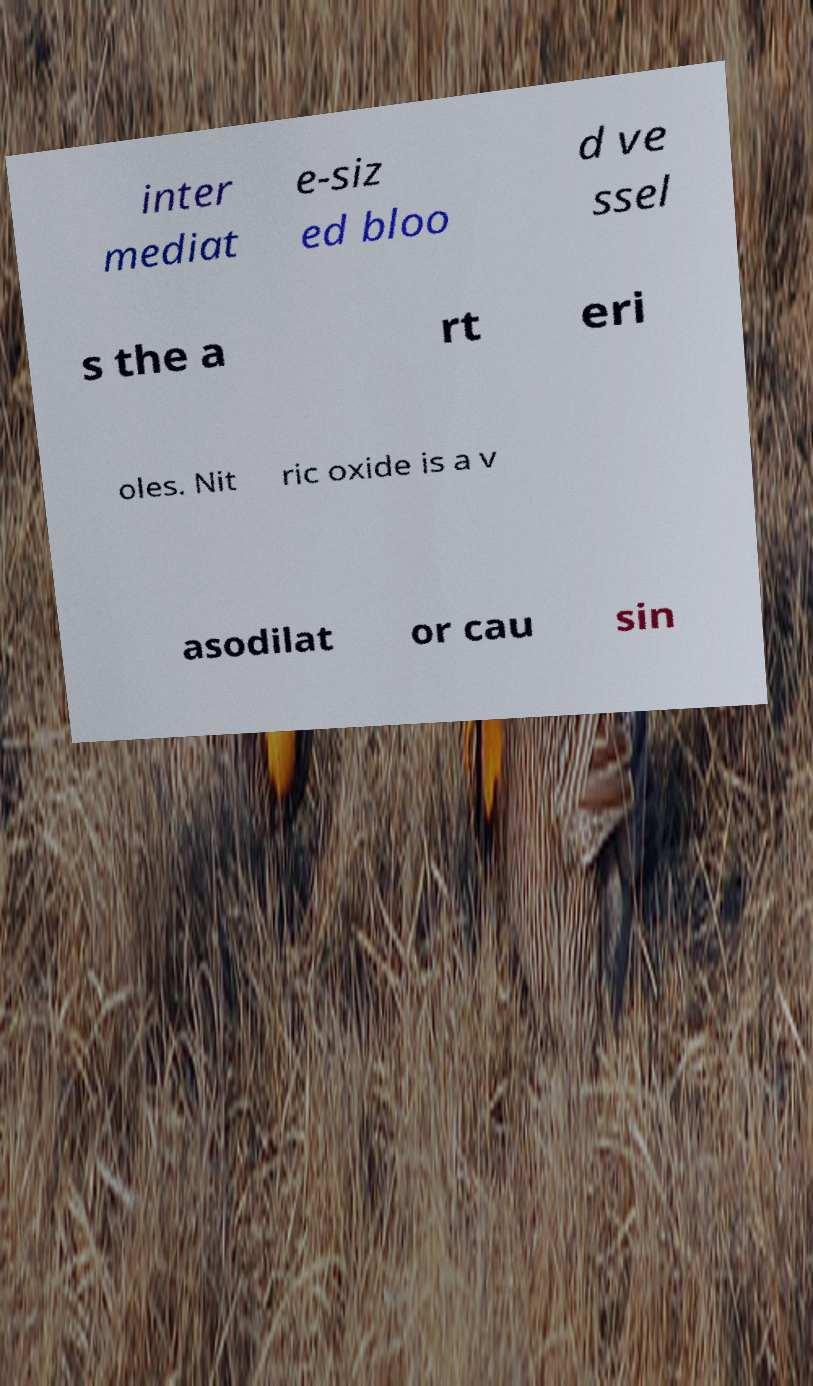Please identify and transcribe the text found in this image. inter mediat e-siz ed bloo d ve ssel s the a rt eri oles. Nit ric oxide is a v asodilat or cau sin 